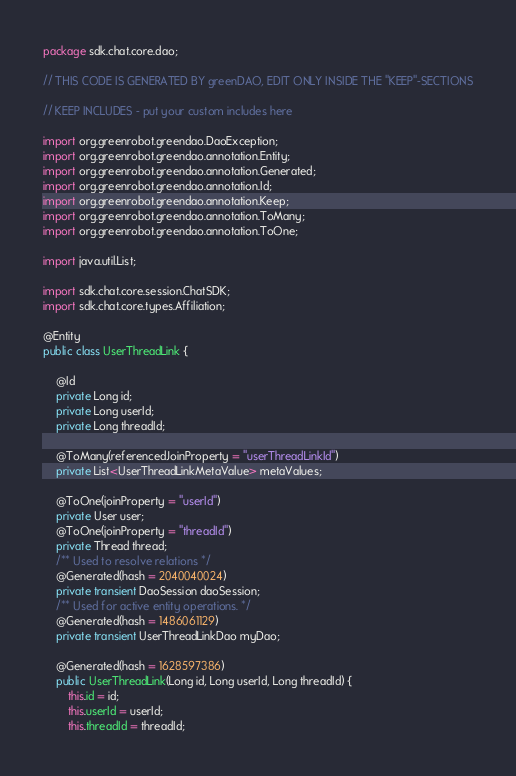Convert code to text. <code><loc_0><loc_0><loc_500><loc_500><_Java_>package sdk.chat.core.dao;

// THIS CODE IS GENERATED BY greenDAO, EDIT ONLY INSIDE THE "KEEP"-SECTIONS

// KEEP INCLUDES - put your custom includes here

import org.greenrobot.greendao.DaoException;
import org.greenrobot.greendao.annotation.Entity;
import org.greenrobot.greendao.annotation.Generated;
import org.greenrobot.greendao.annotation.Id;
import org.greenrobot.greendao.annotation.Keep;
import org.greenrobot.greendao.annotation.ToMany;
import org.greenrobot.greendao.annotation.ToOne;

import java.util.List;

import sdk.chat.core.session.ChatSDK;
import sdk.chat.core.types.Affiliation;

@Entity
public class UserThreadLink {

    @Id
    private Long id;
    private Long userId;
    private Long threadId;

    @ToMany(referencedJoinProperty = "userThreadLinkId")
    private List<UserThreadLinkMetaValue> metaValues;

    @ToOne(joinProperty = "userId")
    private User user;
    @ToOne(joinProperty = "threadId")
    private Thread thread;
    /** Used to resolve relations */
    @Generated(hash = 2040040024)
    private transient DaoSession daoSession;
    /** Used for active entity operations. */
    @Generated(hash = 1486061129)
    private transient UserThreadLinkDao myDao;

    @Generated(hash = 1628597386)
    public UserThreadLink(Long id, Long userId, Long threadId) {
        this.id = id;
        this.userId = userId;
        this.threadId = threadId;</code> 